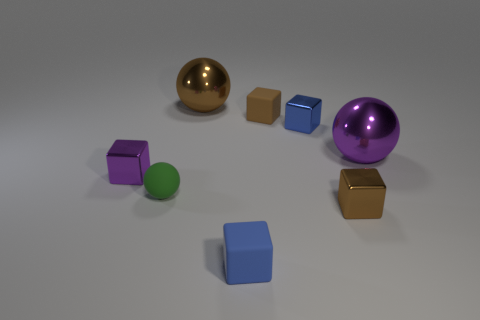If this scene were part of a learning game, what could be the possible objective? If this were a learning game, the objective could involve sorting the objects by color or shape, identifying patterns, or even calculating the volumes of the different geometric shapes to introduce concepts of geometry and spatial awareness. 